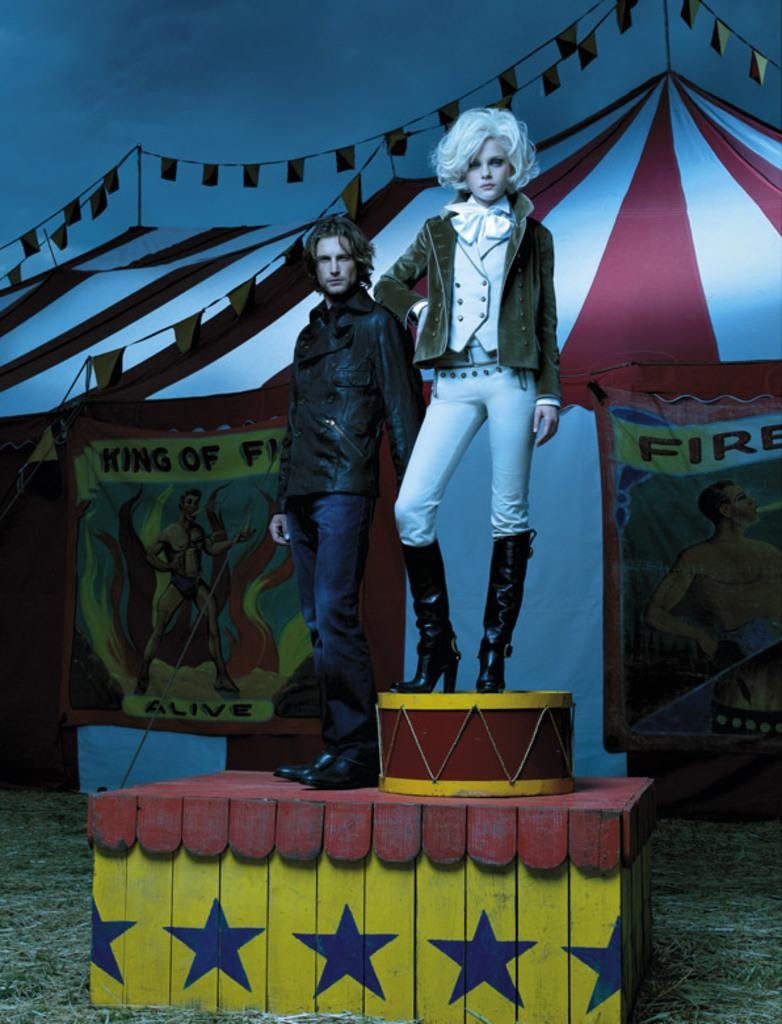What is the man doing in the image? The man is standing on the floor in the image. What is the lady doing in the image? The lady is standing on a musical instrument in the image. What structure is visible behind the two persons? There is a tent behind the two persons in the image. How would you describe the weather based on the image? The sky is cloudy in the image, suggesting a potentially overcast or cloudy day. What channel is the lady playing on the musical instrument in the image? There is no mention of a channel or any electronic device in the image; the lady is simply standing on a musical instrument. Are there any fairies visible in the image? There are no fairies present in the image. 